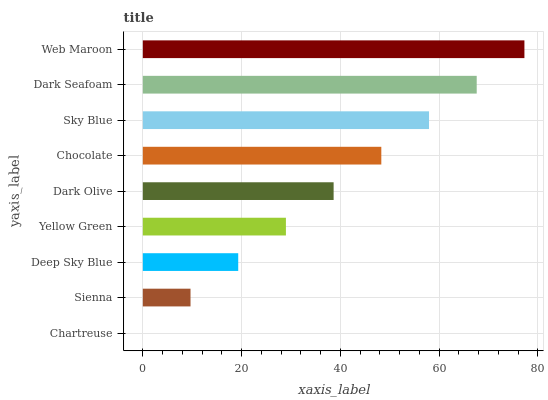Is Chartreuse the minimum?
Answer yes or no. Yes. Is Web Maroon the maximum?
Answer yes or no. Yes. Is Sienna the minimum?
Answer yes or no. No. Is Sienna the maximum?
Answer yes or no. No. Is Sienna greater than Chartreuse?
Answer yes or no. Yes. Is Chartreuse less than Sienna?
Answer yes or no. Yes. Is Chartreuse greater than Sienna?
Answer yes or no. No. Is Sienna less than Chartreuse?
Answer yes or no. No. Is Dark Olive the high median?
Answer yes or no. Yes. Is Dark Olive the low median?
Answer yes or no. Yes. Is Sienna the high median?
Answer yes or no. No. Is Sky Blue the low median?
Answer yes or no. No. 